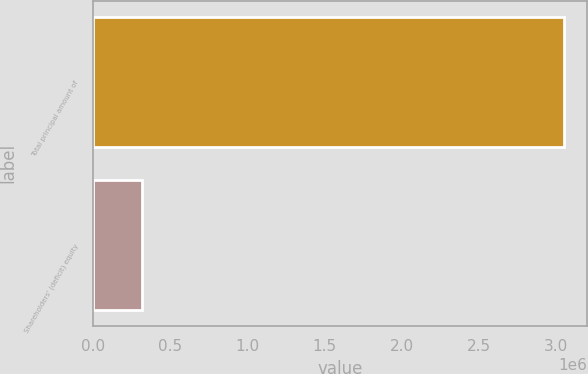<chart> <loc_0><loc_0><loc_500><loc_500><bar_chart><fcel>Total principal amount of<fcel>Shareholders' (deficit) equity<nl><fcel>3.05e+06<fcel>317110<nl></chart> 